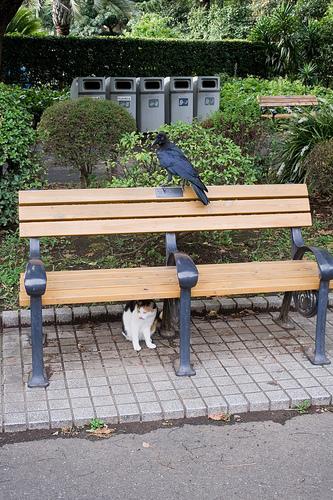How many benches are in the picture?
Be succinct. 2. What number of bricks are under this bench?
Answer briefly. 100. What is underneath the bench?
Quick response, please. Cat. How many people are sitting on the bench?
Be succinct. 0. 